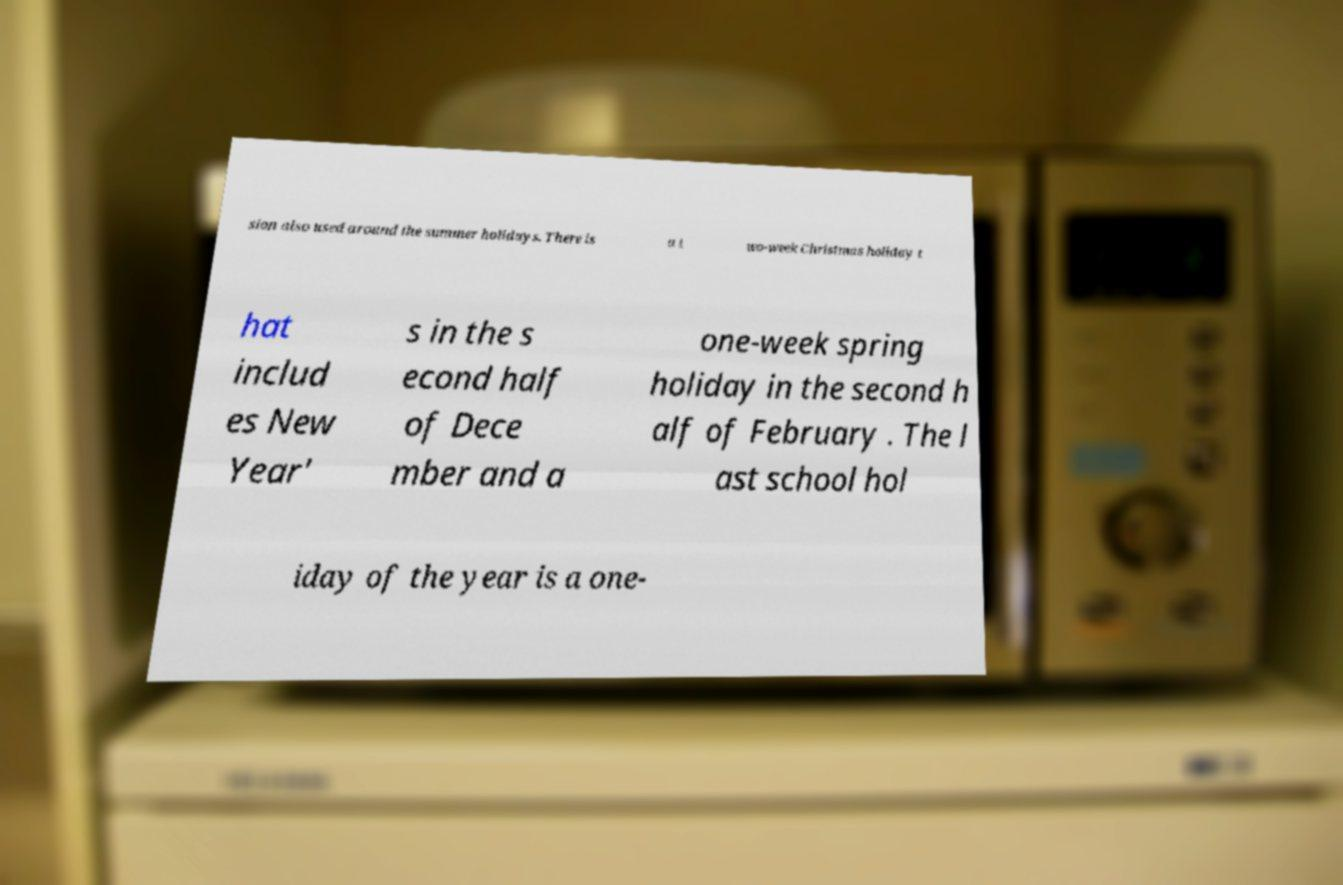I need the written content from this picture converted into text. Can you do that? sion also used around the summer holidays. There is a t wo-week Christmas holiday t hat includ es New Year' s in the s econd half of Dece mber and a one-week spring holiday in the second h alf of February . The l ast school hol iday of the year is a one- 